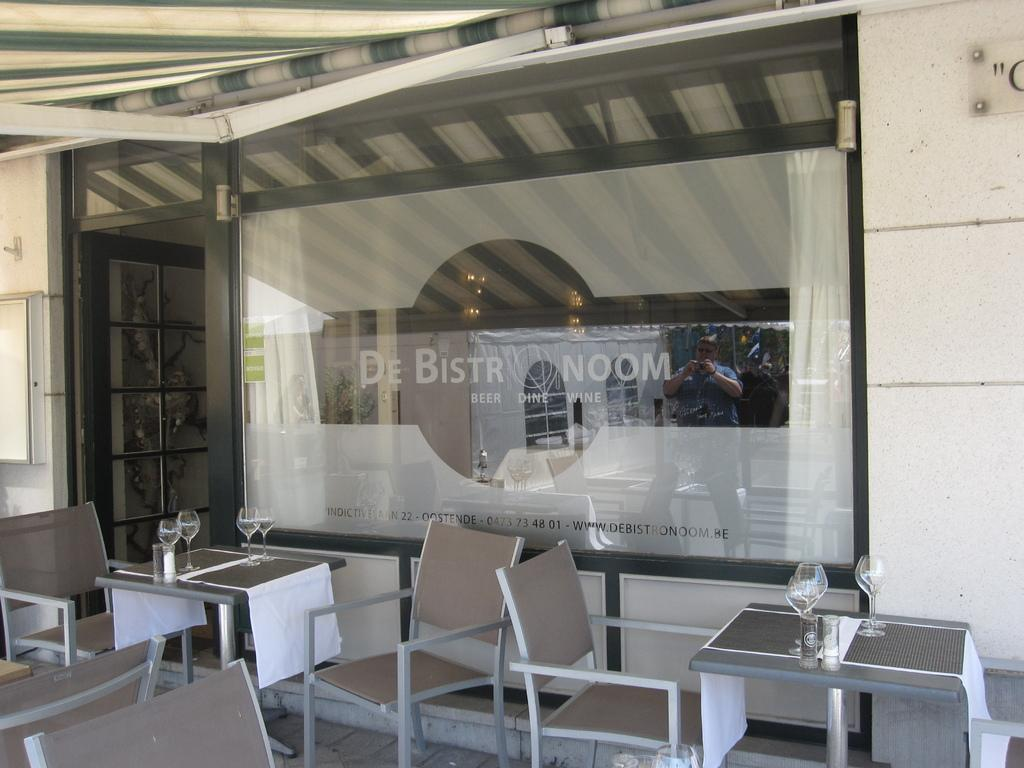<image>
Create a compact narrative representing the image presented. Empty tables are ready for customers outside of De Bistro Noom beer dine and wine. 